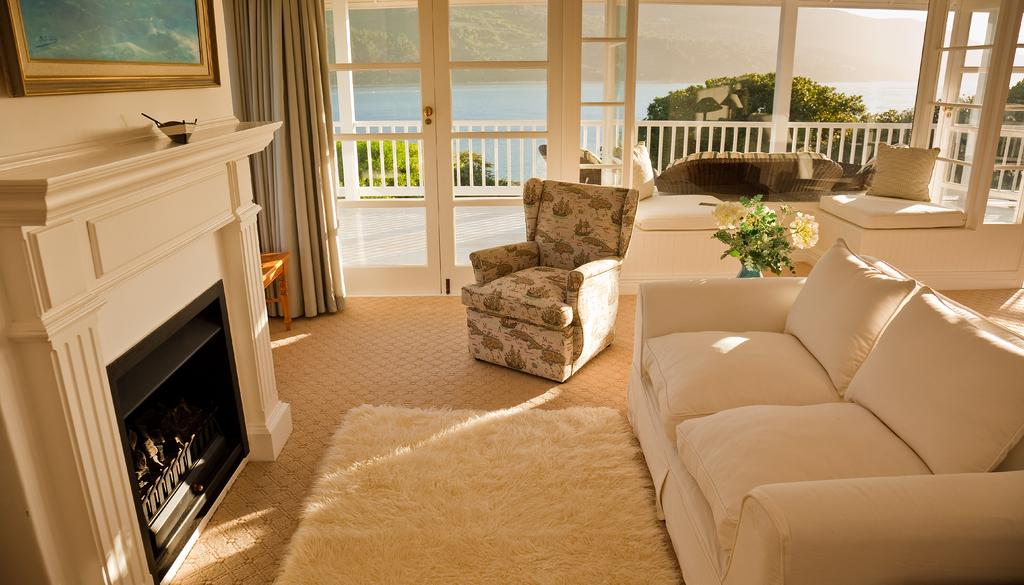What type of space is depicted in the image? There is a room in the image. What furniture is present in the room? There is a sofa in the room. Are there any decorative items in the room? Yes, there is a vase with flowers in the room. What architectural feature can be seen in the room? There is a fireplace in the room. What window treatment is present in the room? There are windows with curtains in the room. Are there any wall decorations in the room? Yes, there are frames on the walls. What type of honey is being served on the leather sofa in the image? There is no honey or leather sofa present in the image. 